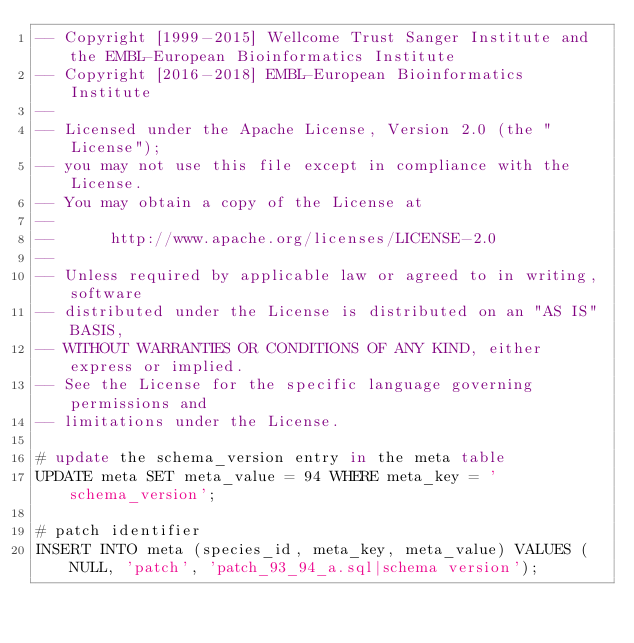Convert code to text. <code><loc_0><loc_0><loc_500><loc_500><_SQL_>-- Copyright [1999-2015] Wellcome Trust Sanger Institute and the EMBL-European Bioinformatics Institute
-- Copyright [2016-2018] EMBL-European Bioinformatics Institute
-- 
-- Licensed under the Apache License, Version 2.0 (the "License");
-- you may not use this file except in compliance with the License.
-- You may obtain a copy of the License at
-- 
--      http://www.apache.org/licenses/LICENSE-2.0
-- 
-- Unless required by applicable law or agreed to in writing, software
-- distributed under the License is distributed on an "AS IS" BASIS,
-- WITHOUT WARRANTIES OR CONDITIONS OF ANY KIND, either express or implied.
-- See the License for the specific language governing permissions and
-- limitations under the License.

# update the schema_version entry in the meta table
UPDATE meta SET meta_value = 94 WHERE meta_key = 'schema_version';

# patch identifier
INSERT INTO meta (species_id, meta_key, meta_value) VALUES (NULL, 'patch', 'patch_93_94_a.sql|schema version');

</code> 